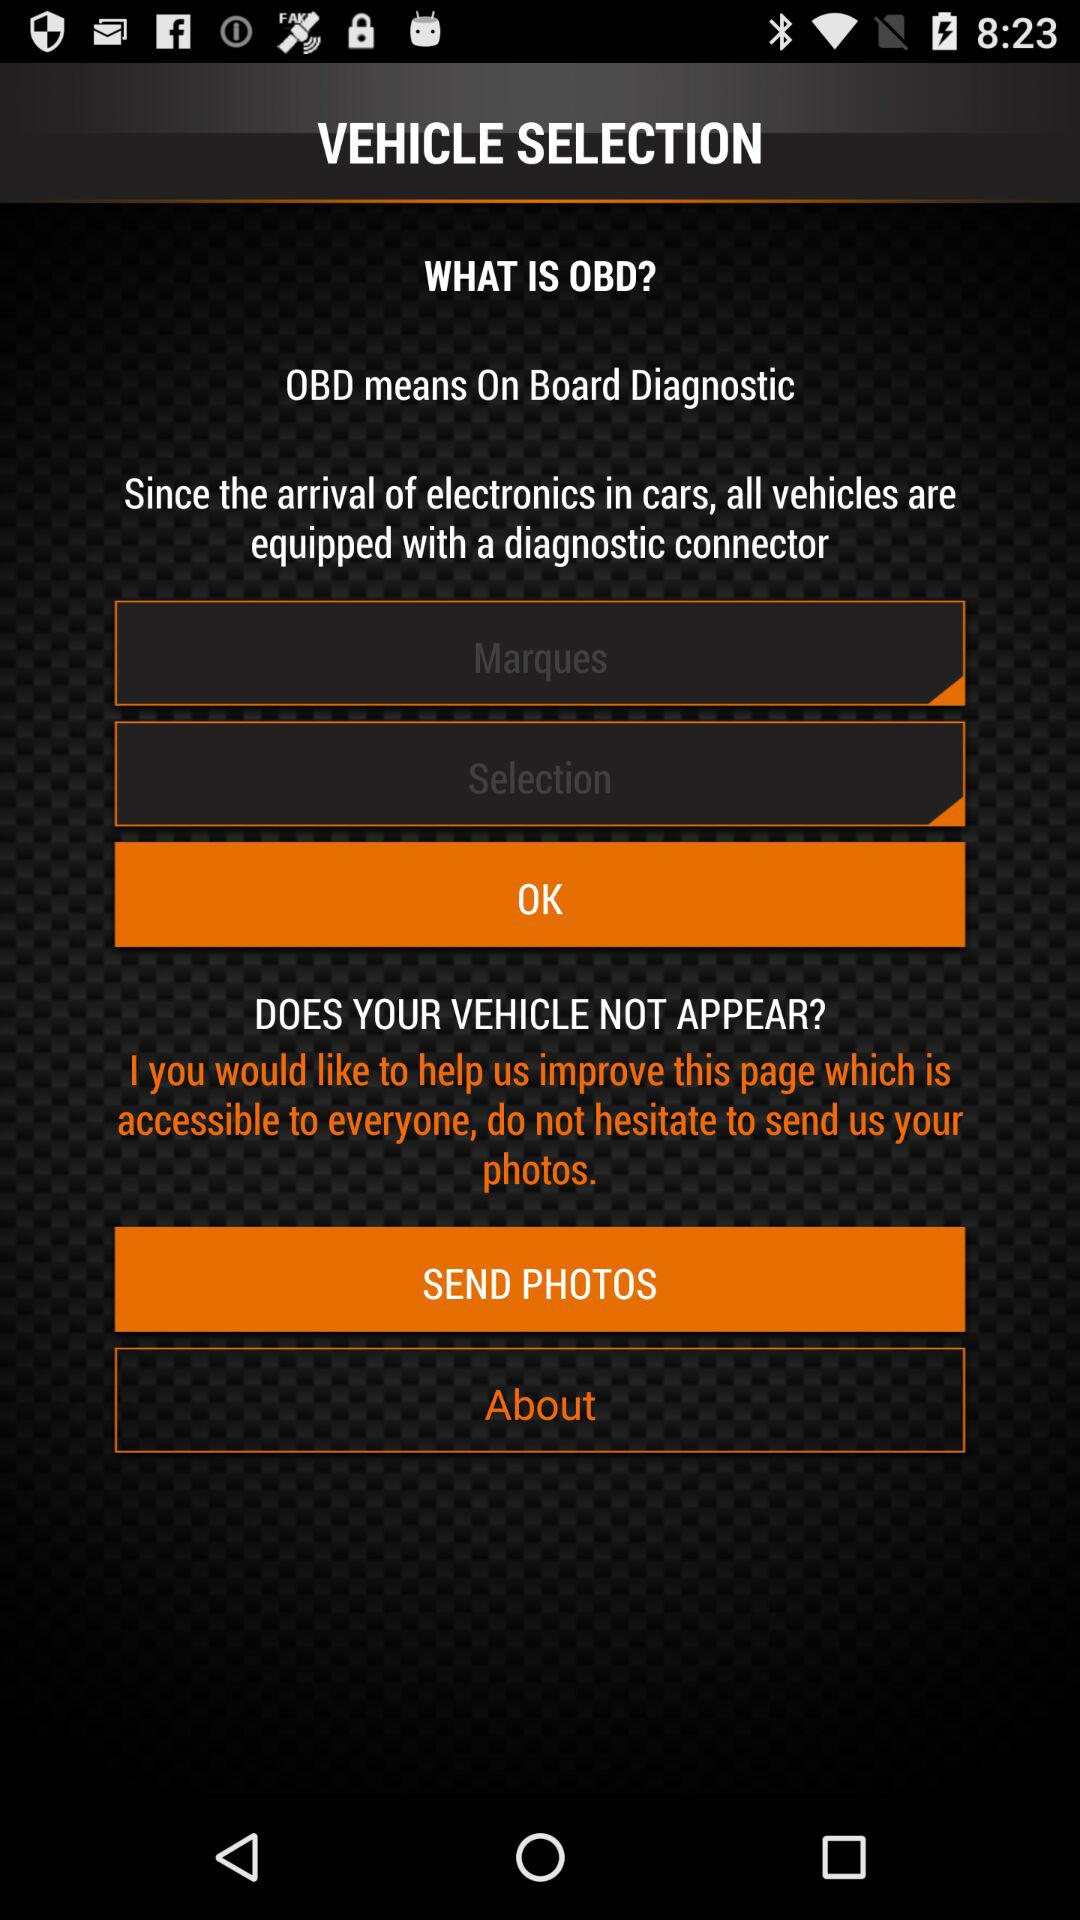What is the full form of OBD? The full form of OBD is On Board Diagnostic. 